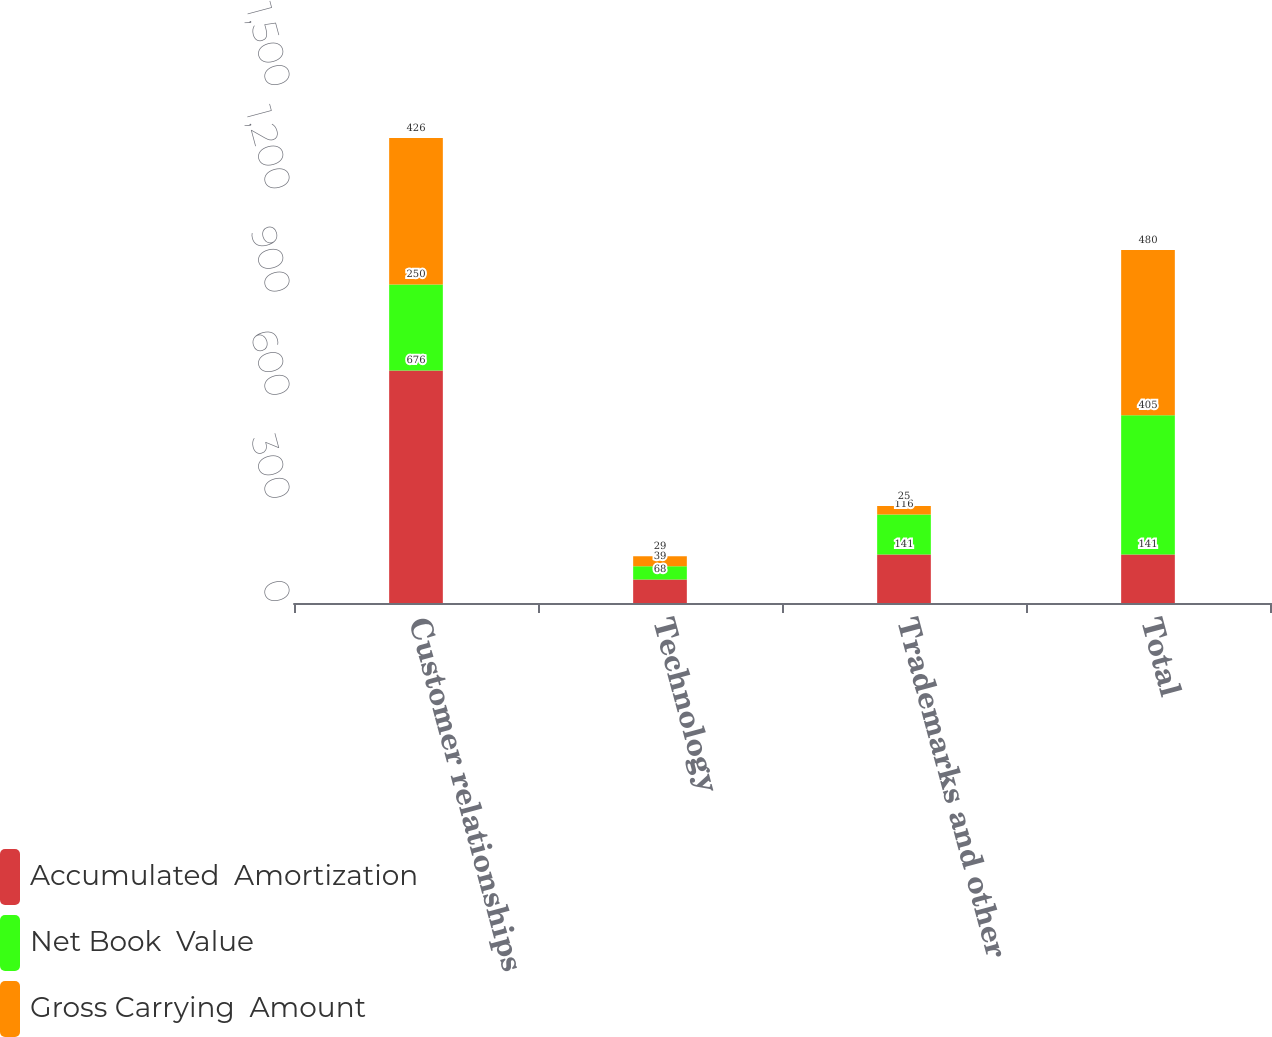Convert chart. <chart><loc_0><loc_0><loc_500><loc_500><stacked_bar_chart><ecel><fcel>Customer relationships<fcel>Technology<fcel>Trademarks and other<fcel>Total<nl><fcel>Accumulated  Amortization<fcel>676<fcel>68<fcel>141<fcel>141<nl><fcel>Net Book  Value<fcel>250<fcel>39<fcel>116<fcel>405<nl><fcel>Gross Carrying  Amount<fcel>426<fcel>29<fcel>25<fcel>480<nl></chart> 